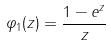<formula> <loc_0><loc_0><loc_500><loc_500>\varphi _ { 1 } ( z ) = \frac { 1 - e ^ { z } } { z }</formula> 